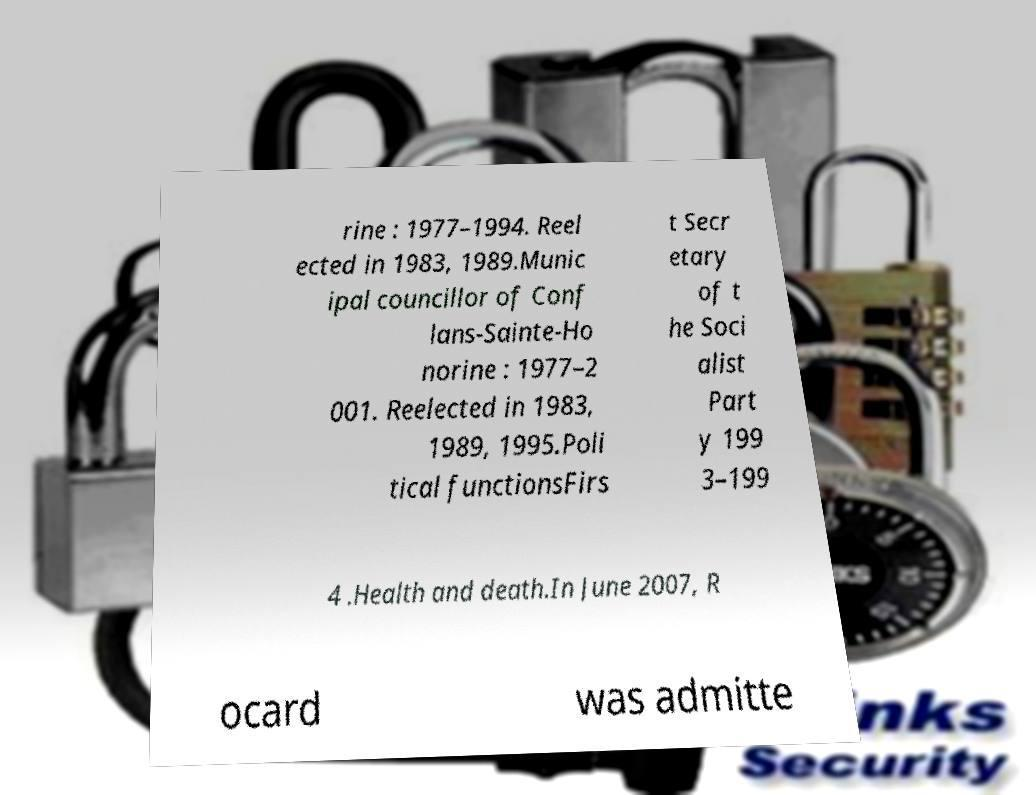Can you accurately transcribe the text from the provided image for me? rine : 1977–1994. Reel ected in 1983, 1989.Munic ipal councillor of Conf lans-Sainte-Ho norine : 1977–2 001. Reelected in 1983, 1989, 1995.Poli tical functionsFirs t Secr etary of t he Soci alist Part y 199 3–199 4 .Health and death.In June 2007, R ocard was admitte 